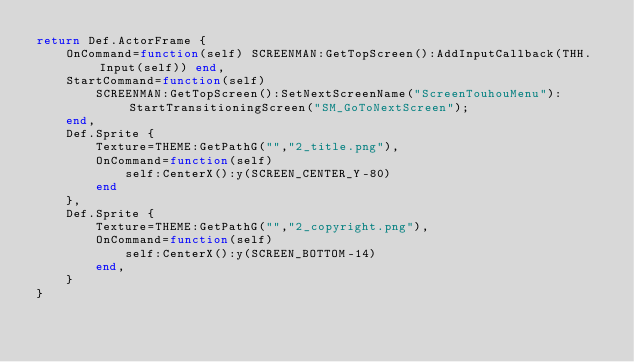<code> <loc_0><loc_0><loc_500><loc_500><_Lua_>return Def.ActorFrame {	
	OnCommand=function(self) SCREENMAN:GetTopScreen():AddInputCallback(THH.Input(self)) end,
	StartCommand=function(self)
		SCREENMAN:GetTopScreen():SetNextScreenName("ScreenTouhouMenu"):StartTransitioningScreen("SM_GoToNextScreen");
	end,
	Def.Sprite {
        Texture=THEME:GetPathG("","2_title.png"),
        OnCommand=function(self)
            self:CenterX():y(SCREEN_CENTER_Y-80)
        end
	},
	Def.Sprite {
        Texture=THEME:GetPathG("","2_copyright.png"),
        OnCommand=function(self)
            self:CenterX():y(SCREEN_BOTTOM-14)
        end,
	}
}
</code> 